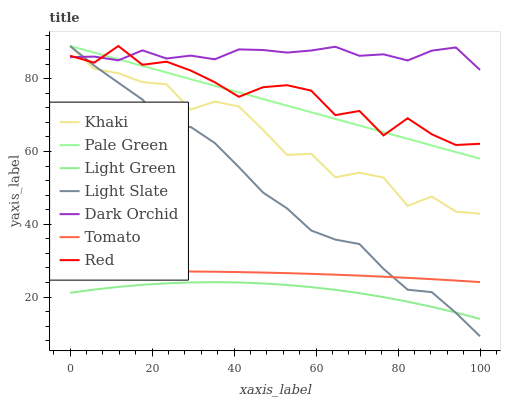Does Light Green have the minimum area under the curve?
Answer yes or no. Yes. Does Dark Orchid have the maximum area under the curve?
Answer yes or no. Yes. Does Khaki have the minimum area under the curve?
Answer yes or no. No. Does Khaki have the maximum area under the curve?
Answer yes or no. No. Is Pale Green the smoothest?
Answer yes or no. Yes. Is Khaki the roughest?
Answer yes or no. Yes. Is Light Slate the smoothest?
Answer yes or no. No. Is Light Slate the roughest?
Answer yes or no. No. Does Khaki have the lowest value?
Answer yes or no. No. Does Dark Orchid have the highest value?
Answer yes or no. No. Is Tomato less than Khaki?
Answer yes or no. Yes. Is Khaki greater than Light Green?
Answer yes or no. Yes. Does Tomato intersect Khaki?
Answer yes or no. No. 